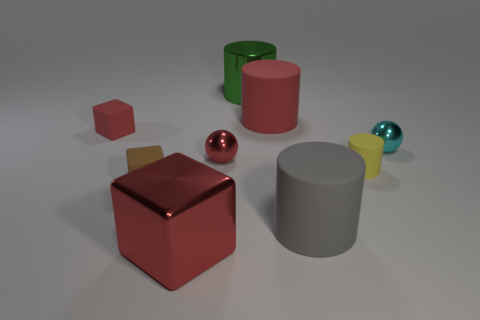Subtract all blocks. How many objects are left? 6 Add 5 large green things. How many large green things exist? 6 Subtract 0 brown cylinders. How many objects are left? 9 Subtract all small red matte objects. Subtract all tiny brown cylinders. How many objects are left? 8 Add 1 big red metal things. How many big red metal things are left? 2 